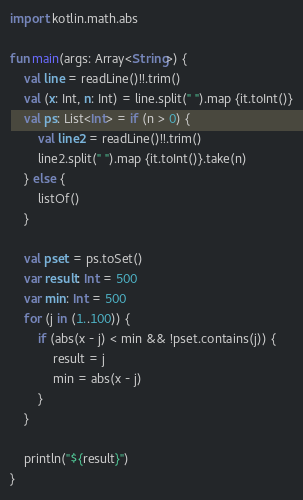<code> <loc_0><loc_0><loc_500><loc_500><_Kotlin_>import kotlin.math.abs

fun main(args: Array<String>) {
    val line = readLine()!!.trim()
    val (x: Int, n: Int) = line.split(" ").map {it.toInt()}
    val ps: List<Int> = if (n > 0) {
        val line2 = readLine()!!.trim()
        line2.split(" ").map {it.toInt()}.take(n)
    } else {
        listOf()
    }

    val pset = ps.toSet()
    var result: Int = 500
    var min: Int = 500
    for (j in (1..100)) {
        if (abs(x - j) < min && !pset.contains(j)) {
            result = j
            min = abs(x - j)
        }
    }

    println("${result}")
}</code> 